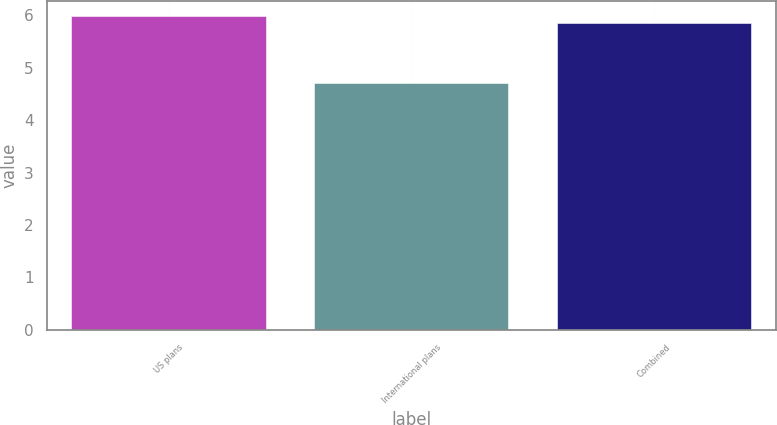Convert chart to OTSL. <chart><loc_0><loc_0><loc_500><loc_500><bar_chart><fcel>US plans<fcel>International plans<fcel>Combined<nl><fcel>5.98<fcel>4.7<fcel>5.86<nl></chart> 